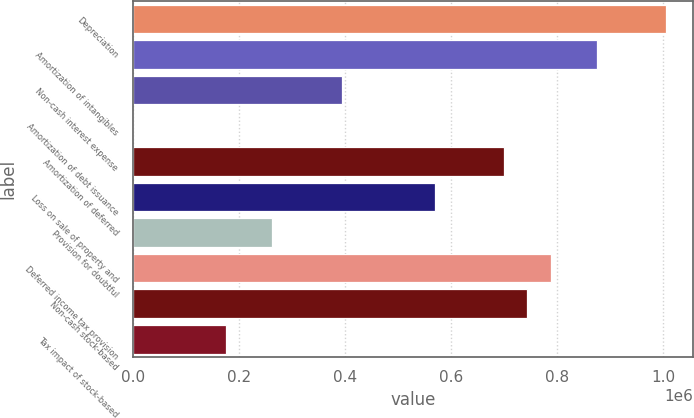Convert chart. <chart><loc_0><loc_0><loc_500><loc_500><bar_chart><fcel>Depreciation<fcel>Amortization of intangibles<fcel>Non-cash interest expense<fcel>Amortization of debt issuance<fcel>Amortization of deferred<fcel>Loss on sale of property and<fcel>Provision for doubtful<fcel>Deferred income tax provision<fcel>Non-cash stock-based<fcel>Tax impact of stock-based<nl><fcel>1.00598e+06<fcel>874881<fcel>394203<fcel>921<fcel>700089<fcel>568995<fcel>263109<fcel>787485<fcel>743787<fcel>175713<nl></chart> 